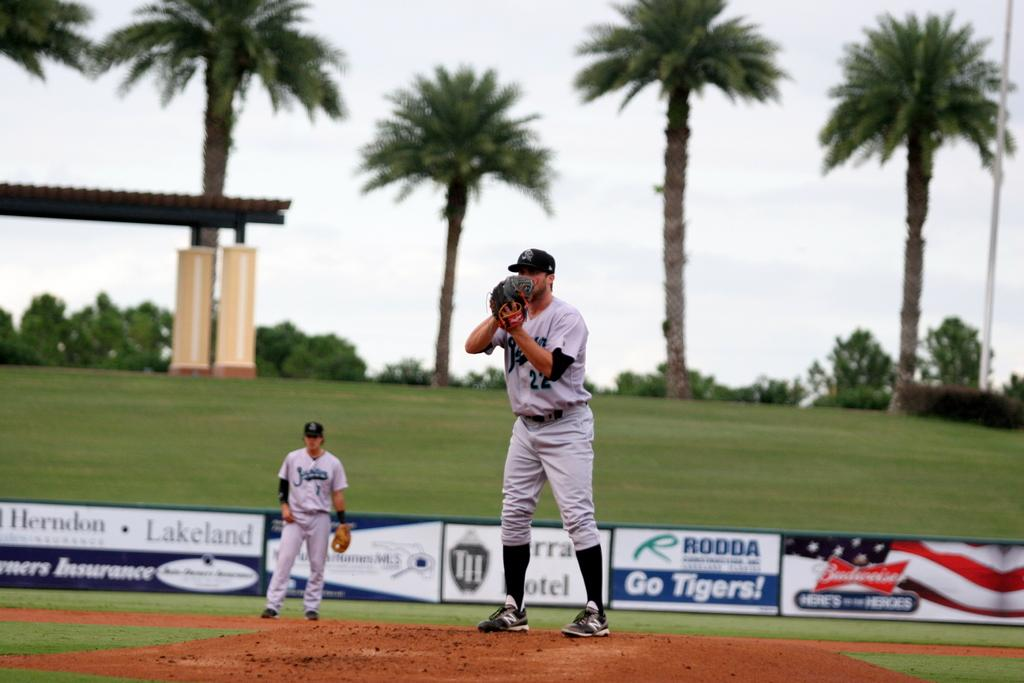<image>
Give a short and clear explanation of the subsequent image. Two baseball players on a field in front of a sign that says "Go Tigers!" 